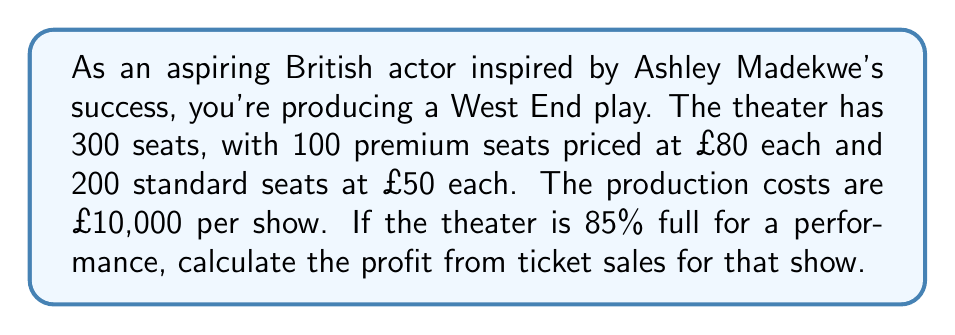Solve this math problem. Let's break this down step-by-step:

1. Calculate the number of seats sold:
   Total seats = 300
   Occupancy rate = 85% = 0.85
   Seats sold = $300 \times 0.85 = 255$

2. Calculate the number of premium and standard seats sold:
   Assuming the same occupancy rate for both types:
   Premium seats sold = $100 \times 0.85 = 85$
   Standard seats sold = $200 \times 0.85 = 170$

3. Calculate the revenue from premium seats:
   Revenue (premium) = $85 \times £80 = £6,800$

4. Calculate the revenue from standard seats:
   Revenue (standard) = $170 \times £50 = £8,500$

5. Calculate the total revenue:
   Total revenue = $£6,800 + £8,500 = £15,300$

6. Calculate the profit:
   Profit = Total revenue - Production costs
   $$ \text{Profit} = £15,300 - £10,000 = £5,300 $$
Answer: The profit from ticket sales for the theater production is £5,300. 